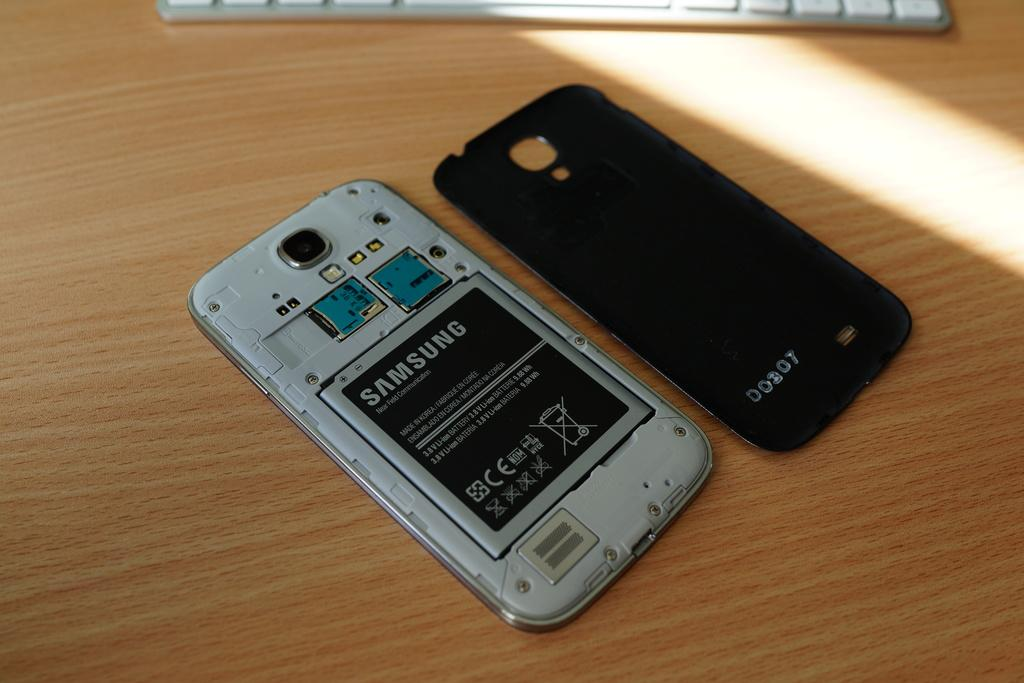Provide a one-sentence caption for the provided image. A phone is opened up, facing down, with a Samsung brand battery in it. 